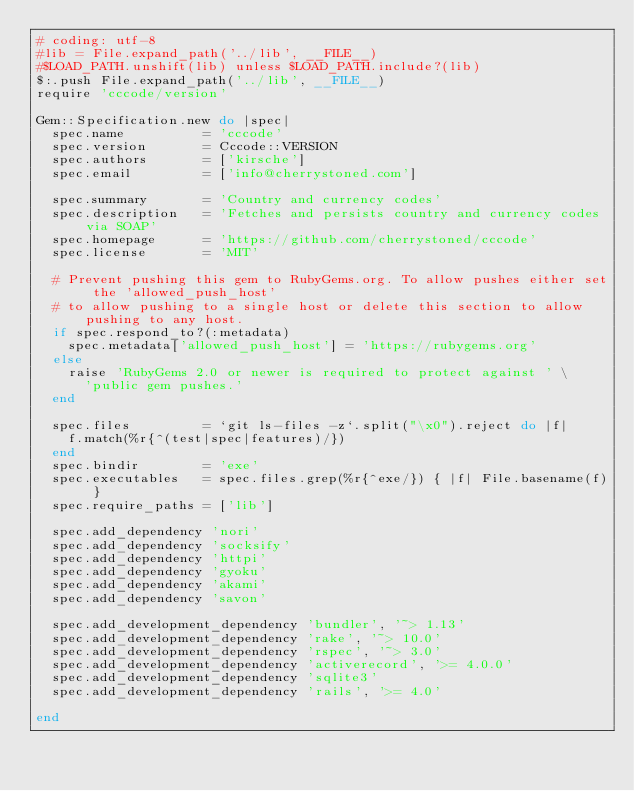<code> <loc_0><loc_0><loc_500><loc_500><_Ruby_># coding: utf-8
#lib = File.expand_path('../lib', __FILE__)
#$LOAD_PATH.unshift(lib) unless $LOAD_PATH.include?(lib)
$:.push File.expand_path('../lib', __FILE__)
require 'cccode/version'

Gem::Specification.new do |spec|
  spec.name          = 'cccode'
  spec.version       = Cccode::VERSION
  spec.authors       = ['kirsche']
  spec.email         = ['info@cherrystoned.com']

  spec.summary       = 'Country and currency codes'
  spec.description   = 'Fetches and persists country and currency codes via SOAP'
  spec.homepage      = 'https://github.com/cherrystoned/cccode'
  spec.license       = 'MIT'

  # Prevent pushing this gem to RubyGems.org. To allow pushes either set the 'allowed_push_host'
  # to allow pushing to a single host or delete this section to allow pushing to any host.
  if spec.respond_to?(:metadata)
    spec.metadata['allowed_push_host'] = 'https://rubygems.org'
  else
    raise 'RubyGems 2.0 or newer is required to protect against ' \
      'public gem pushes.'
  end

  spec.files         = `git ls-files -z`.split("\x0").reject do |f|
    f.match(%r{^(test|spec|features)/})
  end
  spec.bindir        = 'exe'
  spec.executables   = spec.files.grep(%r{^exe/}) { |f| File.basename(f) }
  spec.require_paths = ['lib']
  
  spec.add_dependency 'nori'
  spec.add_dependency 'socksify'
  spec.add_dependency 'httpi'
  spec.add_dependency 'gyoku'
  spec.add_dependency 'akami'
  spec.add_dependency 'savon'
  
  spec.add_development_dependency 'bundler', '~> 1.13'
  spec.add_development_dependency 'rake', '~> 10.0'
  spec.add_development_dependency 'rspec', '~> 3.0'
  spec.add_development_dependency 'activerecord', '>= 4.0.0'
  spec.add_development_dependency 'sqlite3'
  spec.add_development_dependency 'rails', '>= 4.0'
  
end
</code> 